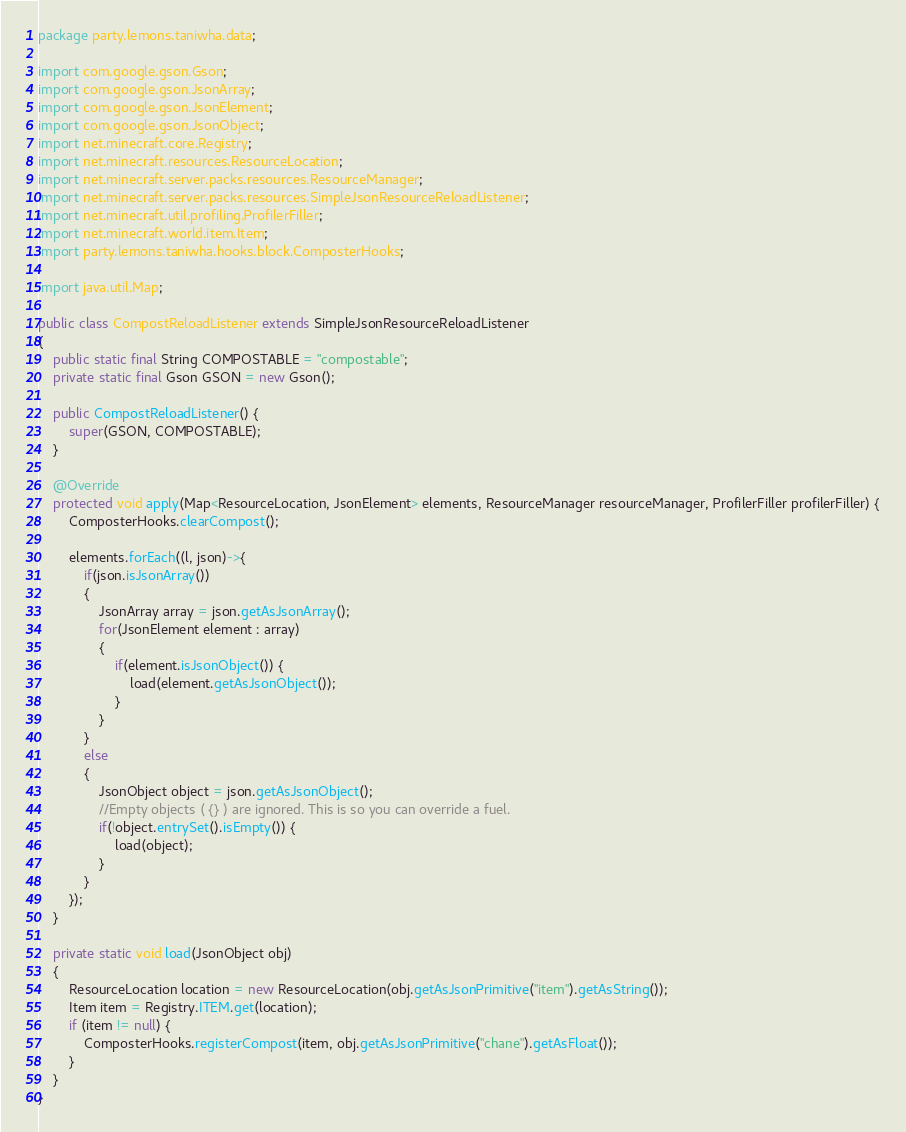<code> <loc_0><loc_0><loc_500><loc_500><_Java_>package party.lemons.taniwha.data;

import com.google.gson.Gson;
import com.google.gson.JsonArray;
import com.google.gson.JsonElement;
import com.google.gson.JsonObject;
import net.minecraft.core.Registry;
import net.minecraft.resources.ResourceLocation;
import net.minecraft.server.packs.resources.ResourceManager;
import net.minecraft.server.packs.resources.SimpleJsonResourceReloadListener;
import net.minecraft.util.profiling.ProfilerFiller;
import net.minecraft.world.item.Item;
import party.lemons.taniwha.hooks.block.ComposterHooks;

import java.util.Map;

public class CompostReloadListener extends SimpleJsonResourceReloadListener
{
    public static final String COMPOSTABLE = "compostable";
    private static final Gson GSON = new Gson();

    public CompostReloadListener() {
        super(GSON, COMPOSTABLE);
    }

    @Override
    protected void apply(Map<ResourceLocation, JsonElement> elements, ResourceManager resourceManager, ProfilerFiller profilerFiller) {
        ComposterHooks.clearCompost();

        elements.forEach((l, json)->{
            if(json.isJsonArray())
            {
                JsonArray array = json.getAsJsonArray();
                for(JsonElement element : array)
                {
                    if(element.isJsonObject()) {
                        load(element.getAsJsonObject());
                    }
                }
            }
            else
            {
                JsonObject object = json.getAsJsonObject();
                //Empty objects ( {} ) are ignored. This is so you can override a fuel.
                if(!object.entrySet().isEmpty()) {
                    load(object);
                }
            }
        });
    }

    private static void load(JsonObject obj)
    {
        ResourceLocation location = new ResourceLocation(obj.getAsJsonPrimitive("item").getAsString());
        Item item = Registry.ITEM.get(location);
        if (item != null) {
            ComposterHooks.registerCompost(item, obj.getAsJsonPrimitive("chane").getAsFloat());
        }
    }
}
</code> 